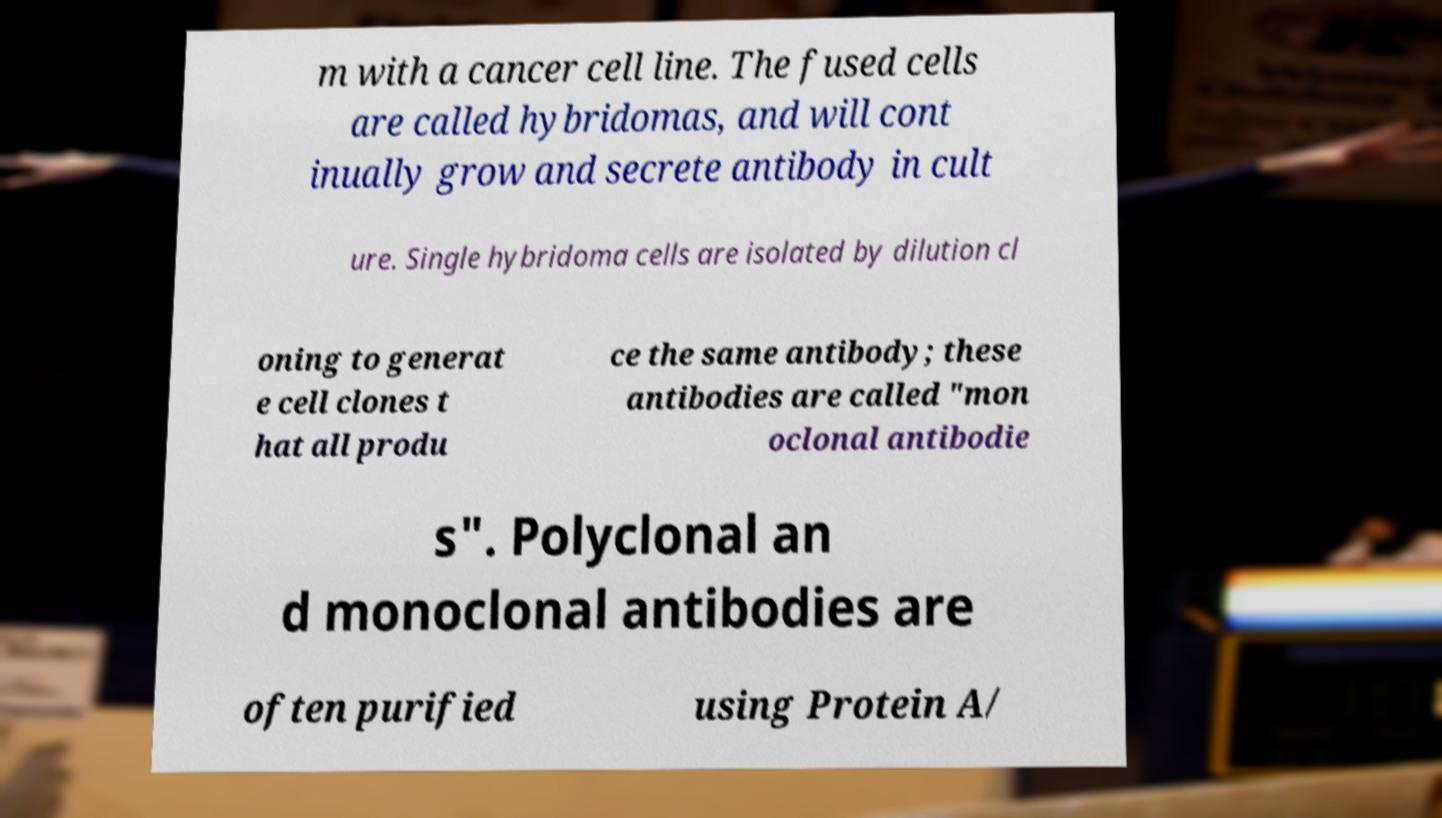I need the written content from this picture converted into text. Can you do that? m with a cancer cell line. The fused cells are called hybridomas, and will cont inually grow and secrete antibody in cult ure. Single hybridoma cells are isolated by dilution cl oning to generat e cell clones t hat all produ ce the same antibody; these antibodies are called "mon oclonal antibodie s". Polyclonal an d monoclonal antibodies are often purified using Protein A/ 